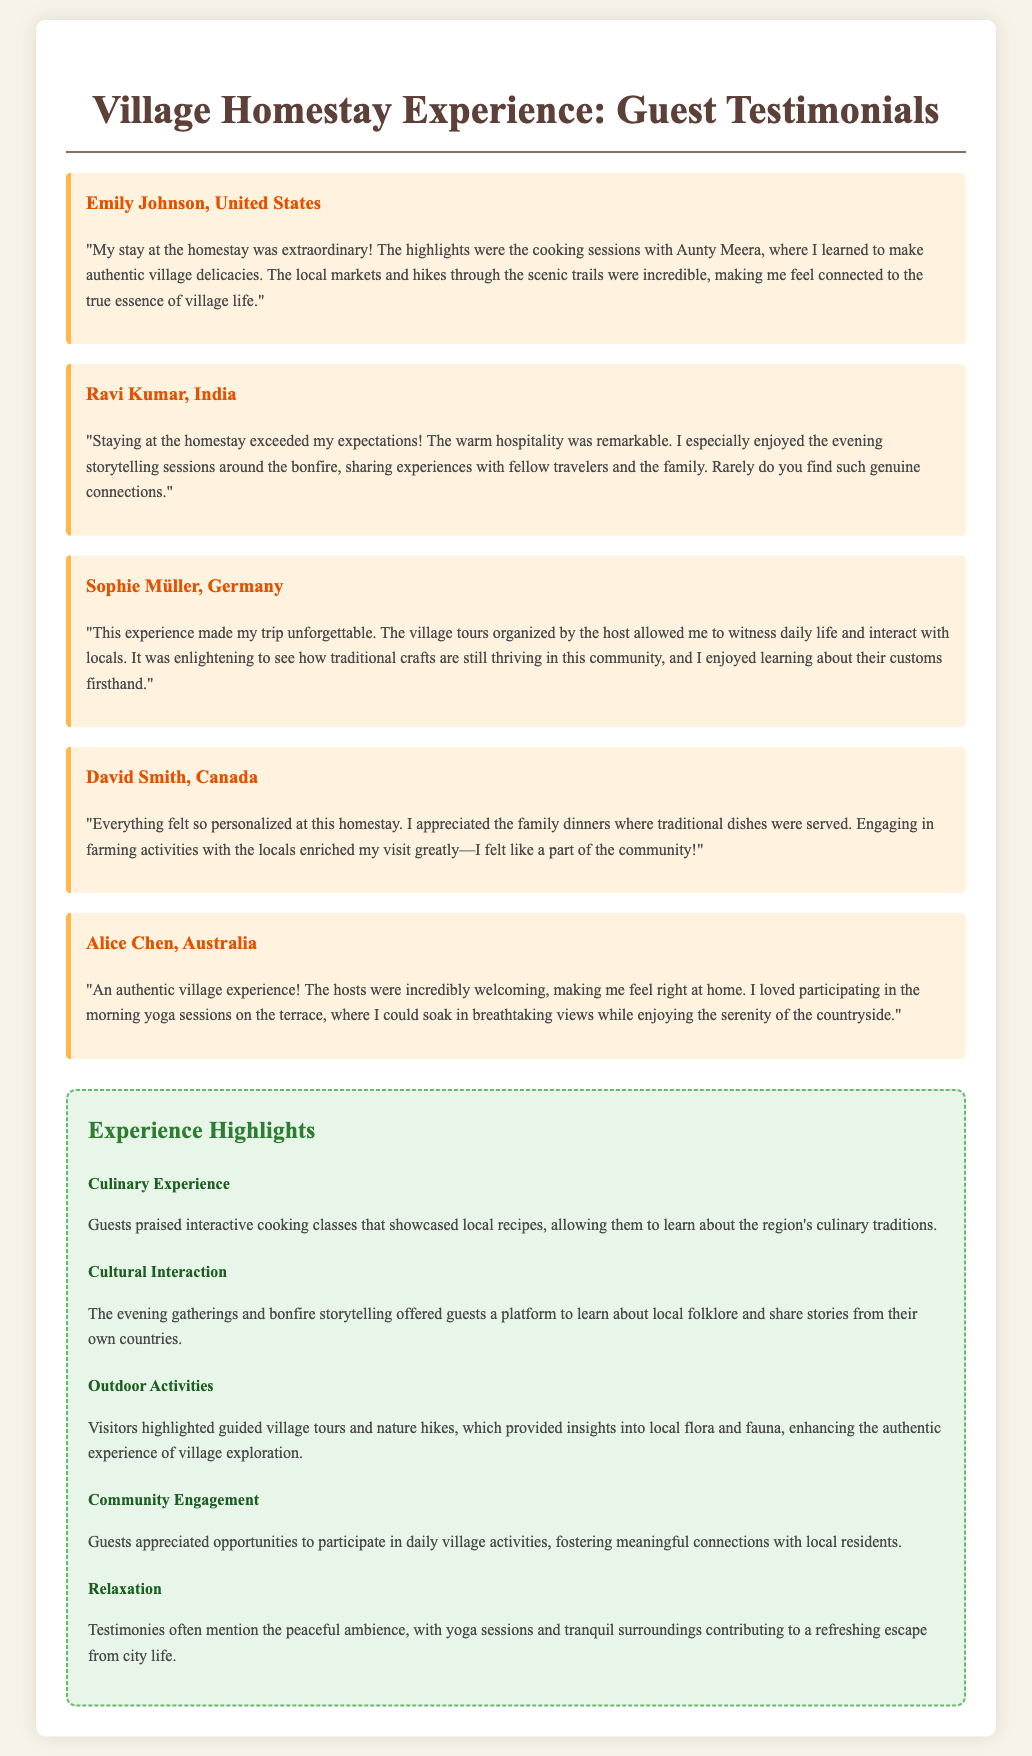What is the name of the testimonial from the United States? Emily Johnson provided a testimonial from the United States.
Answer: Emily Johnson Who conducted the cooking sessions mentioned in the testimonials? Aunty Meera is mentioned as the person leading the cooking sessions.
Answer: Aunty Meera Which guest enjoyed community engagement through farming activities? David Smith specifically mentioned participating in farming activities with locals.
Answer: David Smith What activity did Alice Chen participate in to enhance her relaxation? Morning yoga sessions on the terrace contributed to her relaxation.
Answer: Morning yoga sessions How many guest testimonials are featured in the document? There are five guest testimonials presented in the document.
Answer: Five What type of experience is highlighted related to local folklore? Evening gatherings and bonfire storytelling are highlighted for learning about local folklore.
Answer: Evening gatherings and bonfire storytelling Which country is Sophie Müller from? Sophie Müller is from Germany, as stated in her testimonial.
Answer: Germany What aspect of village life did guests appreciate based on their reviews? Guests appreciated the authenticity of interactions with local residents.
Answer: Authenticity of interactions 